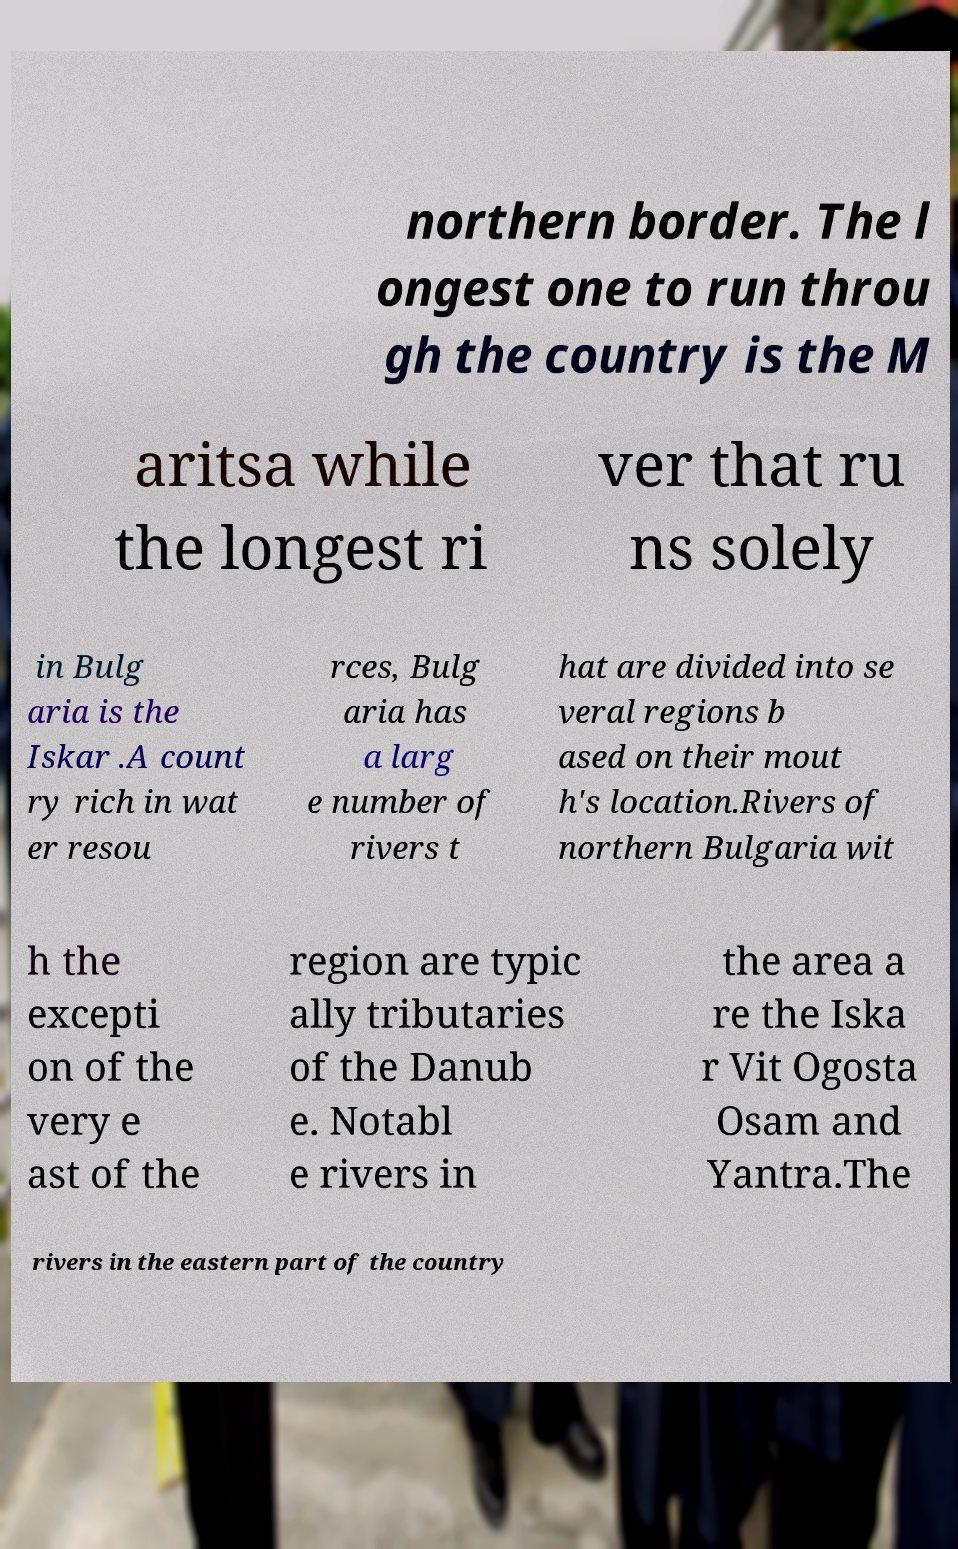Can you read and provide the text displayed in the image?This photo seems to have some interesting text. Can you extract and type it out for me? northern border. The l ongest one to run throu gh the country is the M aritsa while the longest ri ver that ru ns solely in Bulg aria is the Iskar .A count ry rich in wat er resou rces, Bulg aria has a larg e number of rivers t hat are divided into se veral regions b ased on their mout h's location.Rivers of northern Bulgaria wit h the excepti on of the very e ast of the region are typic ally tributaries of the Danub e. Notabl e rivers in the area a re the Iska r Vit Ogosta Osam and Yantra.The rivers in the eastern part of the country 